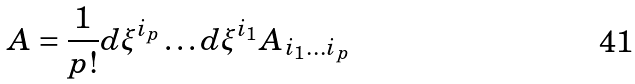Convert formula to latex. <formula><loc_0><loc_0><loc_500><loc_500>A = \frac { 1 } { p ! } d \xi ^ { i _ { p } } \dots d \xi ^ { i _ { 1 } } A _ { i _ { 1 } \dots i _ { p } }</formula> 